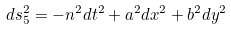<formula> <loc_0><loc_0><loc_500><loc_500>d s _ { 5 } ^ { 2 } = - n ^ { 2 } d t ^ { 2 } + a ^ { 2 } d { x } ^ { 2 } + b ^ { 2 } d y ^ { 2 }</formula> 